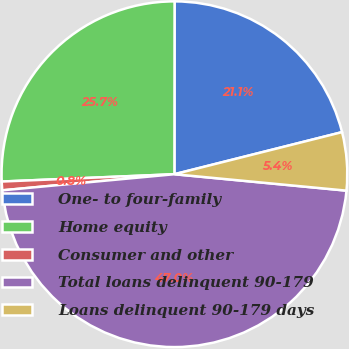<chart> <loc_0><loc_0><loc_500><loc_500><pie_chart><fcel>One- to four-family<fcel>Home equity<fcel>Consumer and other<fcel>Total loans delinquent 90-179<fcel>Loans delinquent 90-179 days<nl><fcel>21.07%<fcel>25.69%<fcel>0.81%<fcel>47.0%<fcel>5.43%<nl></chart> 